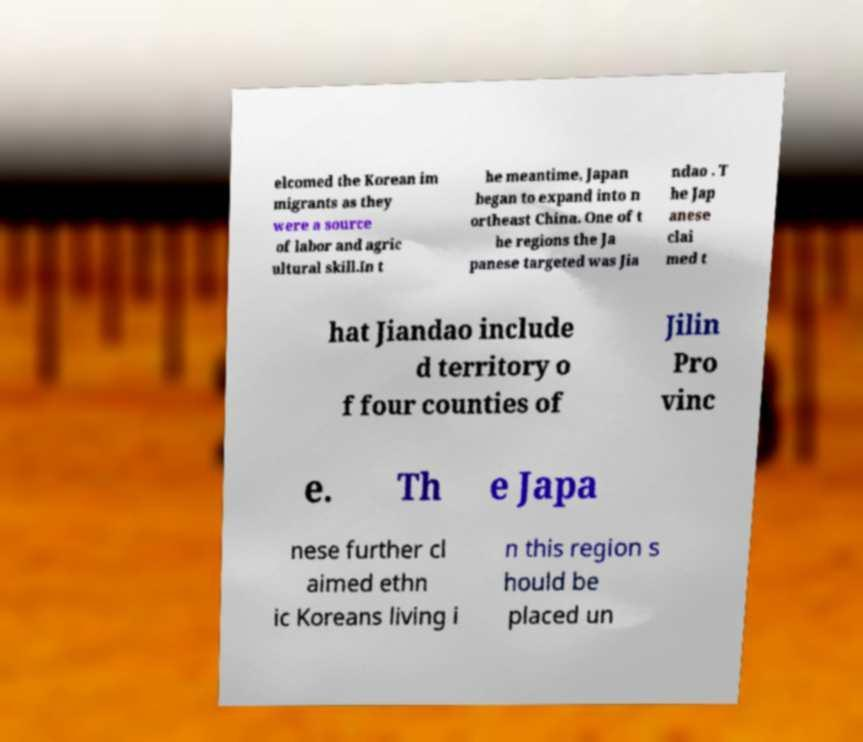For documentation purposes, I need the text within this image transcribed. Could you provide that? elcomed the Korean im migrants as they were a source of labor and agric ultural skill.In t he meantime, Japan began to expand into n ortheast China. One of t he regions the Ja panese targeted was Jia ndao . T he Jap anese clai med t hat Jiandao include d territory o f four counties of Jilin Pro vinc e. Th e Japa nese further cl aimed ethn ic Koreans living i n this region s hould be placed un 